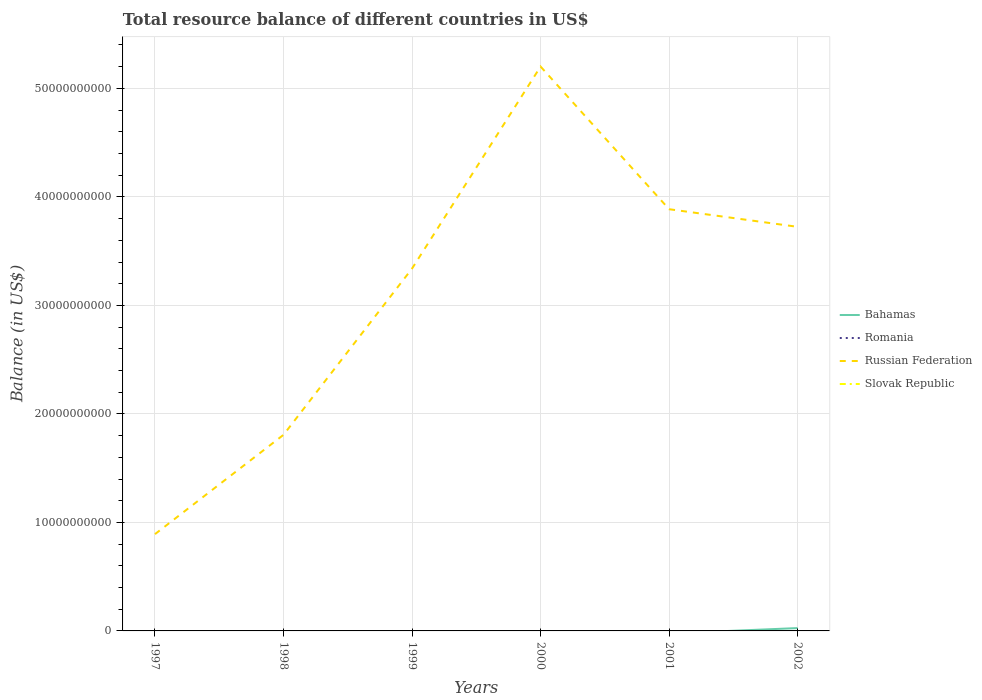Is the number of lines equal to the number of legend labels?
Ensure brevity in your answer.  No. What is the total total resource balance in Russian Federation in the graph?
Keep it short and to the point. -1.92e+1. What is the difference between the highest and the second highest total resource balance in Bahamas?
Make the answer very short. 2.62e+08. What is the difference between the highest and the lowest total resource balance in Romania?
Offer a very short reply. 0. How many lines are there?
Your response must be concise. 2. How many years are there in the graph?
Provide a short and direct response. 6. Where does the legend appear in the graph?
Your response must be concise. Center right. How many legend labels are there?
Offer a very short reply. 4. How are the legend labels stacked?
Provide a succinct answer. Vertical. What is the title of the graph?
Ensure brevity in your answer.  Total resource balance of different countries in US$. Does "Turkmenistan" appear as one of the legend labels in the graph?
Provide a short and direct response. No. What is the label or title of the X-axis?
Make the answer very short. Years. What is the label or title of the Y-axis?
Provide a succinct answer. Balance (in US$). What is the Balance (in US$) of Bahamas in 1997?
Offer a terse response. 0. What is the Balance (in US$) in Russian Federation in 1997?
Your response must be concise. 8.92e+09. What is the Balance (in US$) in Russian Federation in 1998?
Make the answer very short. 1.81e+1. What is the Balance (in US$) of Slovak Republic in 1998?
Make the answer very short. 0. What is the Balance (in US$) in Bahamas in 1999?
Your response must be concise. 0. What is the Balance (in US$) in Russian Federation in 1999?
Offer a very short reply. 3.34e+1. What is the Balance (in US$) in Romania in 2000?
Your response must be concise. 0. What is the Balance (in US$) of Russian Federation in 2000?
Your response must be concise. 5.20e+1. What is the Balance (in US$) in Slovak Republic in 2000?
Keep it short and to the point. 0. What is the Balance (in US$) in Bahamas in 2001?
Your answer should be compact. 0. What is the Balance (in US$) of Romania in 2001?
Provide a succinct answer. 0. What is the Balance (in US$) of Russian Federation in 2001?
Keep it short and to the point. 3.89e+1. What is the Balance (in US$) of Bahamas in 2002?
Your answer should be compact. 2.62e+08. What is the Balance (in US$) in Romania in 2002?
Keep it short and to the point. 0. What is the Balance (in US$) in Russian Federation in 2002?
Ensure brevity in your answer.  3.72e+1. What is the Balance (in US$) in Slovak Republic in 2002?
Your answer should be very brief. 0. Across all years, what is the maximum Balance (in US$) of Bahamas?
Your answer should be very brief. 2.62e+08. Across all years, what is the maximum Balance (in US$) in Russian Federation?
Make the answer very short. 5.20e+1. Across all years, what is the minimum Balance (in US$) in Bahamas?
Provide a short and direct response. 0. Across all years, what is the minimum Balance (in US$) of Russian Federation?
Your response must be concise. 8.92e+09. What is the total Balance (in US$) of Bahamas in the graph?
Provide a short and direct response. 2.62e+08. What is the total Balance (in US$) of Russian Federation in the graph?
Offer a very short reply. 1.89e+11. What is the difference between the Balance (in US$) of Russian Federation in 1997 and that in 1998?
Ensure brevity in your answer.  -9.15e+09. What is the difference between the Balance (in US$) in Russian Federation in 1997 and that in 1999?
Provide a succinct answer. -2.45e+1. What is the difference between the Balance (in US$) of Russian Federation in 1997 and that in 2000?
Ensure brevity in your answer.  -4.31e+1. What is the difference between the Balance (in US$) of Russian Federation in 1997 and that in 2001?
Provide a succinct answer. -2.99e+1. What is the difference between the Balance (in US$) of Russian Federation in 1997 and that in 2002?
Provide a short and direct response. -2.83e+1. What is the difference between the Balance (in US$) of Russian Federation in 1998 and that in 1999?
Make the answer very short. -1.53e+1. What is the difference between the Balance (in US$) in Russian Federation in 1998 and that in 2000?
Your answer should be very brief. -3.39e+1. What is the difference between the Balance (in US$) in Russian Federation in 1998 and that in 2001?
Provide a short and direct response. -2.08e+1. What is the difference between the Balance (in US$) in Russian Federation in 1998 and that in 2002?
Your response must be concise. -1.92e+1. What is the difference between the Balance (in US$) in Russian Federation in 1999 and that in 2000?
Make the answer very short. -1.86e+1. What is the difference between the Balance (in US$) of Russian Federation in 1999 and that in 2001?
Provide a succinct answer. -5.47e+09. What is the difference between the Balance (in US$) of Russian Federation in 1999 and that in 2002?
Make the answer very short. -3.85e+09. What is the difference between the Balance (in US$) in Russian Federation in 2000 and that in 2001?
Your answer should be very brief. 1.31e+1. What is the difference between the Balance (in US$) in Russian Federation in 2000 and that in 2002?
Make the answer very short. 1.48e+1. What is the difference between the Balance (in US$) in Russian Federation in 2001 and that in 2002?
Ensure brevity in your answer.  1.62e+09. What is the average Balance (in US$) of Bahamas per year?
Offer a terse response. 4.37e+07. What is the average Balance (in US$) in Russian Federation per year?
Provide a short and direct response. 3.14e+1. What is the average Balance (in US$) of Slovak Republic per year?
Offer a terse response. 0. In the year 2002, what is the difference between the Balance (in US$) in Bahamas and Balance (in US$) in Russian Federation?
Your answer should be compact. -3.70e+1. What is the ratio of the Balance (in US$) of Russian Federation in 1997 to that in 1998?
Offer a terse response. 0.49. What is the ratio of the Balance (in US$) in Russian Federation in 1997 to that in 1999?
Provide a short and direct response. 0.27. What is the ratio of the Balance (in US$) of Russian Federation in 1997 to that in 2000?
Make the answer very short. 0.17. What is the ratio of the Balance (in US$) in Russian Federation in 1997 to that in 2001?
Keep it short and to the point. 0.23. What is the ratio of the Balance (in US$) in Russian Federation in 1997 to that in 2002?
Keep it short and to the point. 0.24. What is the ratio of the Balance (in US$) of Russian Federation in 1998 to that in 1999?
Make the answer very short. 0.54. What is the ratio of the Balance (in US$) of Russian Federation in 1998 to that in 2000?
Provide a short and direct response. 0.35. What is the ratio of the Balance (in US$) in Russian Federation in 1998 to that in 2001?
Ensure brevity in your answer.  0.47. What is the ratio of the Balance (in US$) of Russian Federation in 1998 to that in 2002?
Offer a very short reply. 0.49. What is the ratio of the Balance (in US$) of Russian Federation in 1999 to that in 2000?
Ensure brevity in your answer.  0.64. What is the ratio of the Balance (in US$) of Russian Federation in 1999 to that in 2001?
Ensure brevity in your answer.  0.86. What is the ratio of the Balance (in US$) in Russian Federation in 1999 to that in 2002?
Your answer should be compact. 0.9. What is the ratio of the Balance (in US$) of Russian Federation in 2000 to that in 2001?
Keep it short and to the point. 1.34. What is the ratio of the Balance (in US$) in Russian Federation in 2000 to that in 2002?
Offer a terse response. 1.4. What is the ratio of the Balance (in US$) of Russian Federation in 2001 to that in 2002?
Provide a succinct answer. 1.04. What is the difference between the highest and the second highest Balance (in US$) in Russian Federation?
Ensure brevity in your answer.  1.31e+1. What is the difference between the highest and the lowest Balance (in US$) in Bahamas?
Make the answer very short. 2.62e+08. What is the difference between the highest and the lowest Balance (in US$) of Russian Federation?
Provide a succinct answer. 4.31e+1. 